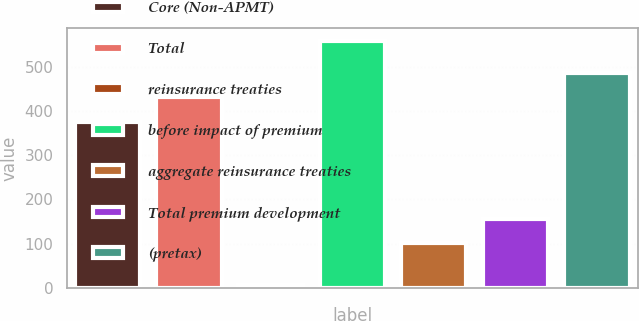Convert chart to OTSL. <chart><loc_0><loc_0><loc_500><loc_500><bar_chart><fcel>Core (Non-APMT)<fcel>Total<fcel>reinsurance treaties<fcel>before impact of premium<fcel>aggregate reinsurance treaties<fcel>Total premium development<fcel>(pretax)<nl><fcel>376<fcel>431.3<fcel>6<fcel>559<fcel>101<fcel>156.3<fcel>486.6<nl></chart> 